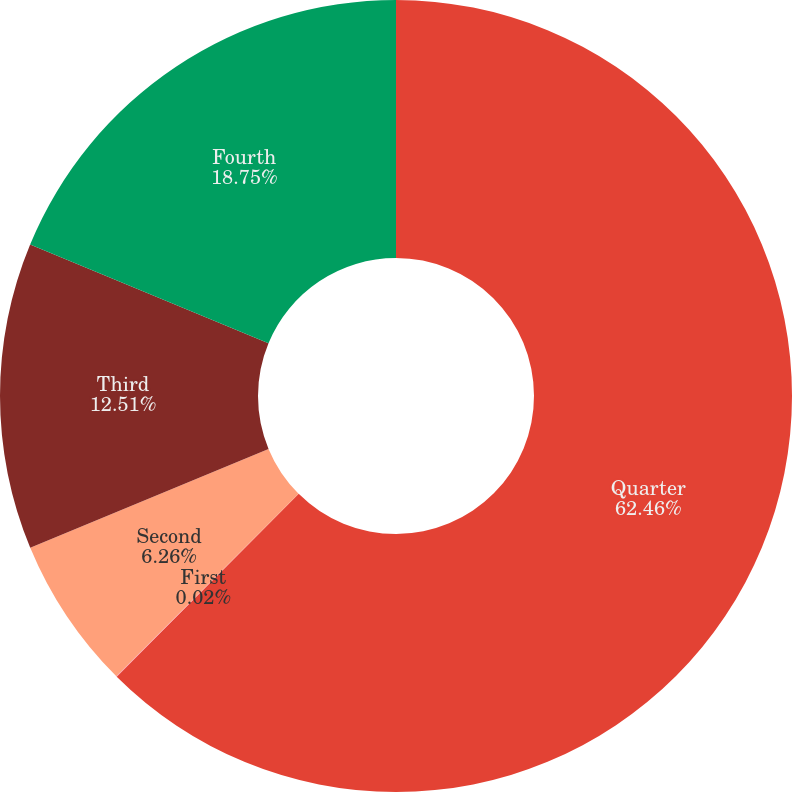<chart> <loc_0><loc_0><loc_500><loc_500><pie_chart><fcel>Quarter<fcel>First<fcel>Second<fcel>Third<fcel>Fourth<nl><fcel>62.46%<fcel>0.02%<fcel>6.26%<fcel>12.51%<fcel>18.75%<nl></chart> 